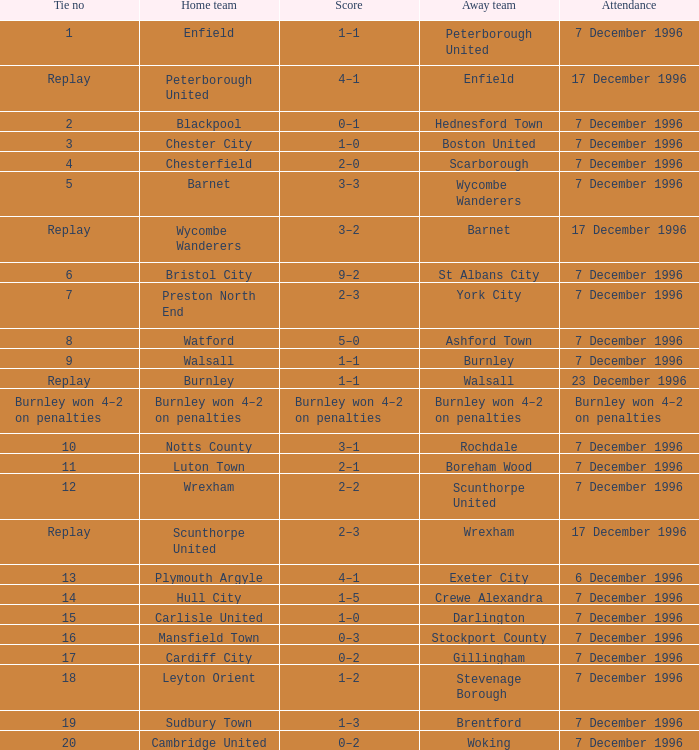Who were the away team in tie number 20? Woking. 